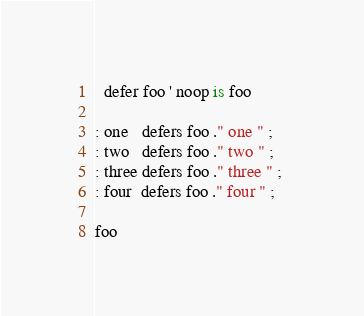<code> <loc_0><loc_0><loc_500><loc_500><_FORTRAN_>
  defer foo ' noop is foo

: one   defers foo ." one " ;
: two   defers foo ." two " ; 
: three defers foo ." three " ; 
: four  defers foo ." four " ;

foo

</code> 